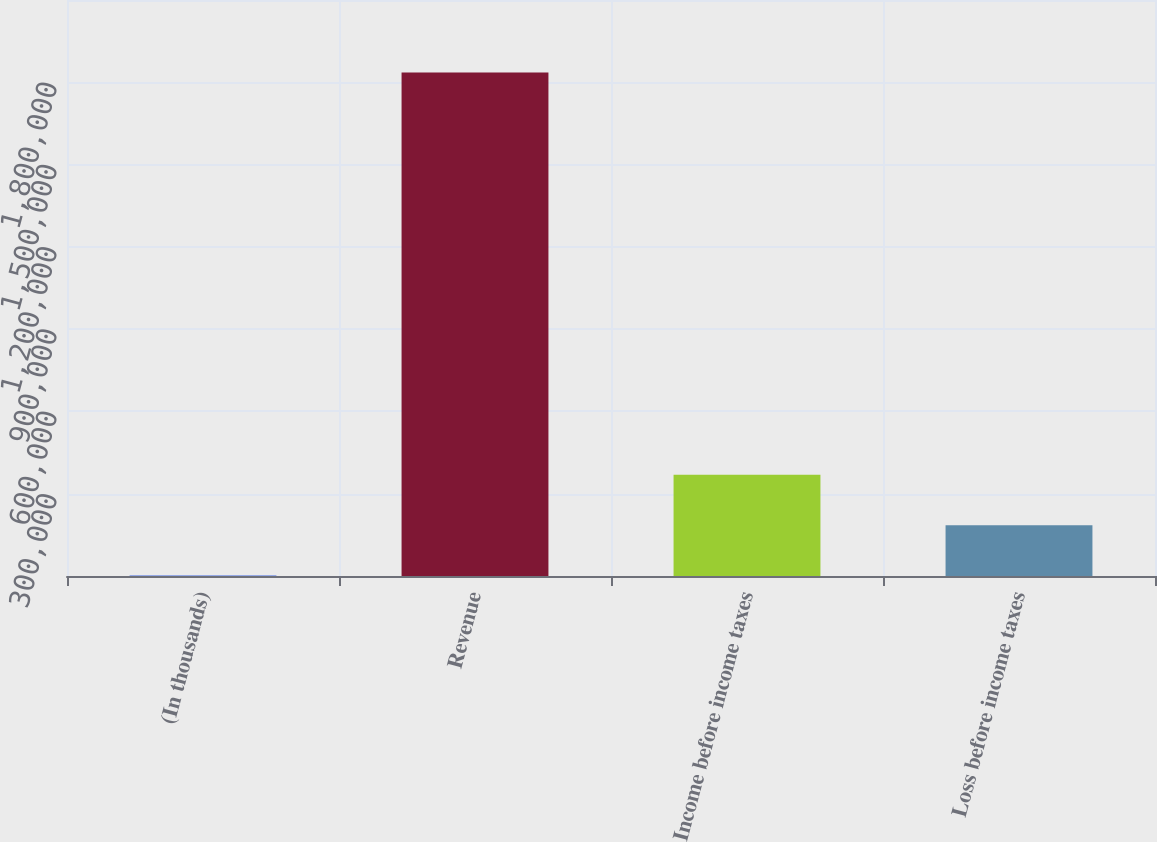<chart> <loc_0><loc_0><loc_500><loc_500><bar_chart><fcel>(In thousands)<fcel>Revenue<fcel>Income before income taxes<fcel>Loss before income taxes<nl><fcel>2012<fcel>1.83582e+06<fcel>368773<fcel>185392<nl></chart> 